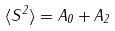<formula> <loc_0><loc_0><loc_500><loc_500>\langle S ^ { 2 } \rangle = A _ { 0 } + A _ { 2 }</formula> 